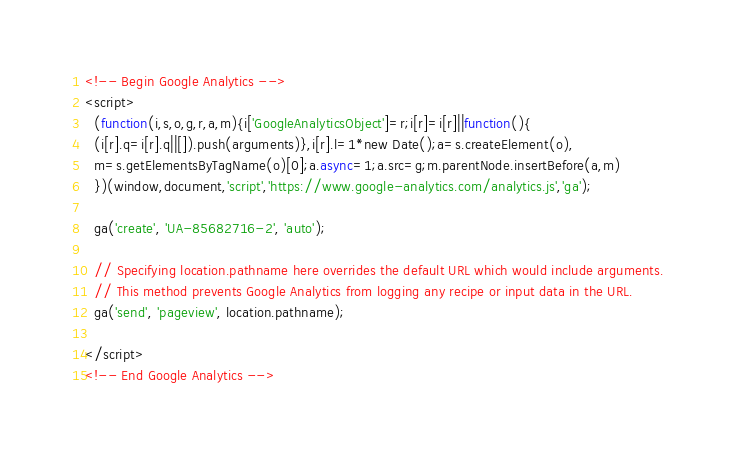<code> <loc_0><loc_0><loc_500><loc_500><_HTML_>

<!-- Begin Google Analytics -->
<script>
  (function(i,s,o,g,r,a,m){i['GoogleAnalyticsObject']=r;i[r]=i[r]||function(){
  (i[r].q=i[r].q||[]).push(arguments)},i[r].l=1*new Date();a=s.createElement(o),
  m=s.getElementsByTagName(o)[0];a.async=1;a.src=g;m.parentNode.insertBefore(a,m)
  })(window,document,'script','https://www.google-analytics.com/analytics.js','ga');

  ga('create', 'UA-85682716-2', 'auto');

  // Specifying location.pathname here overrides the default URL which would include arguments.
  // This method prevents Google Analytics from logging any recipe or input data in the URL.
  ga('send', 'pageview', location.pathname);

</script>
<!-- End Google Analytics -->

</code> 